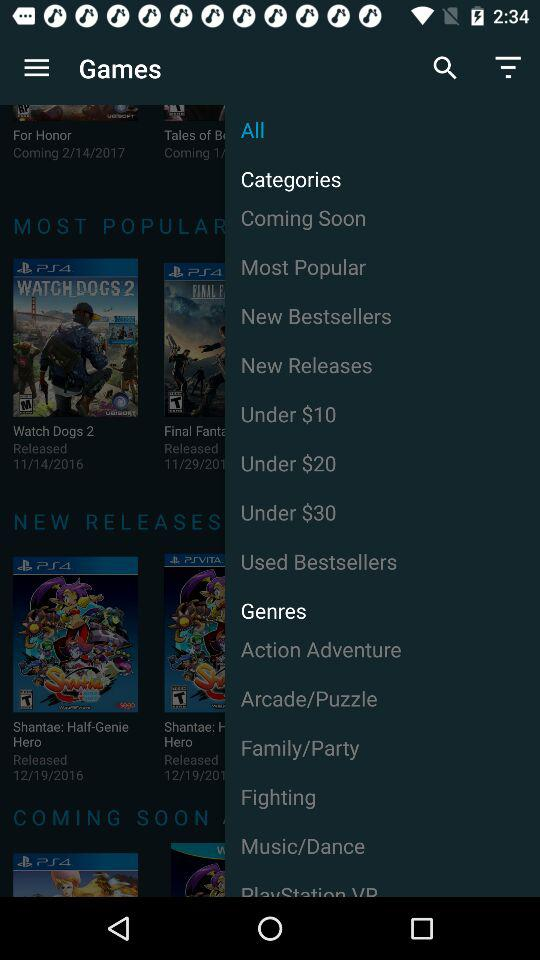What is the application name?
When the provided information is insufficient, respond with <no answer>. <no answer> 